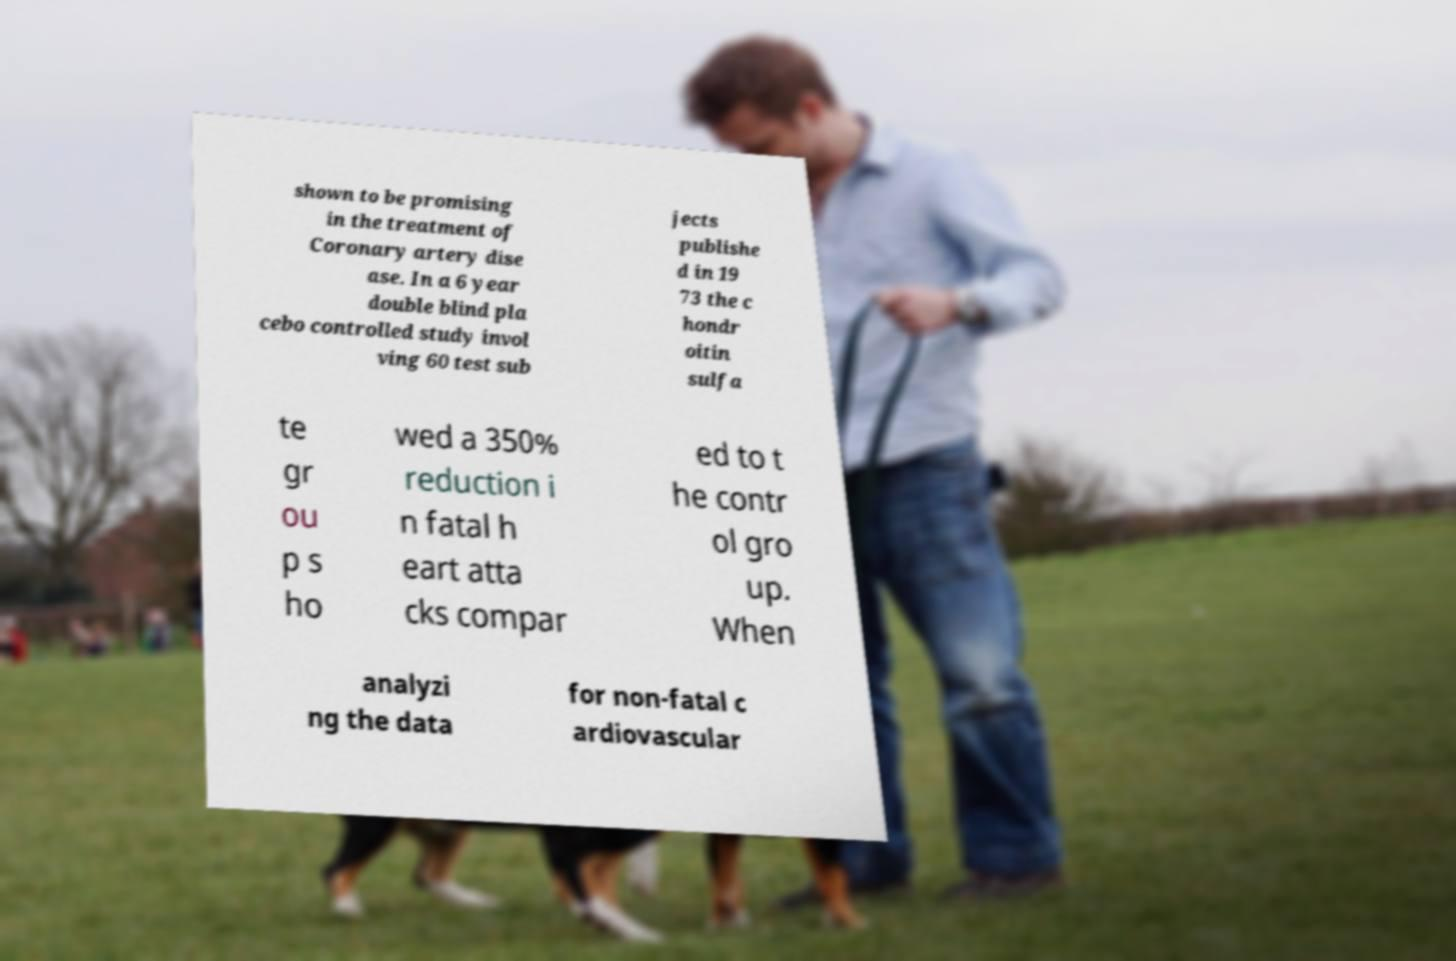Could you extract and type out the text from this image? shown to be promising in the treatment of Coronary artery dise ase. In a 6 year double blind pla cebo controlled study invol ving 60 test sub jects publishe d in 19 73 the c hondr oitin sulfa te gr ou p s ho wed a 350% reduction i n fatal h eart atta cks compar ed to t he contr ol gro up. When analyzi ng the data for non-fatal c ardiovascular 